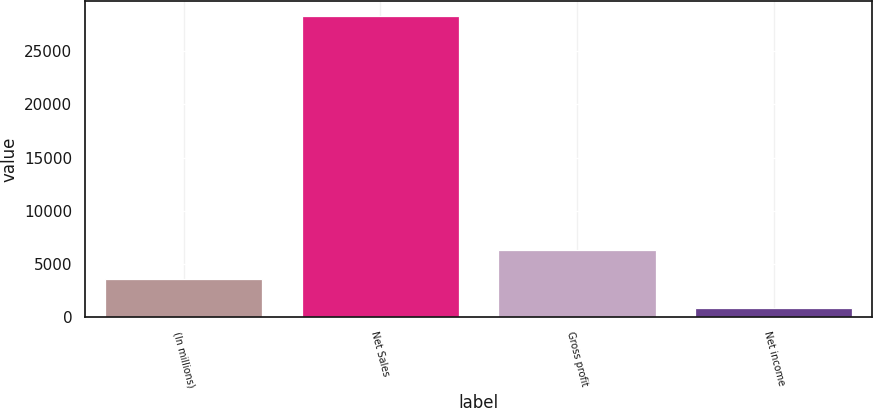Convert chart. <chart><loc_0><loc_0><loc_500><loc_500><bar_chart><fcel>(In millions)<fcel>Net Sales<fcel>Gross profit<fcel>Net income<nl><fcel>3600.9<fcel>28314<fcel>6346.8<fcel>855<nl></chart> 